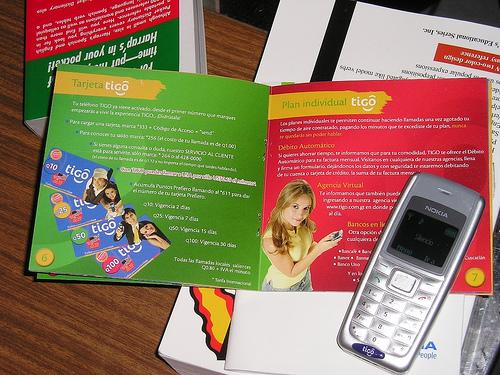What is the silver device on the red paper used for? making calls 